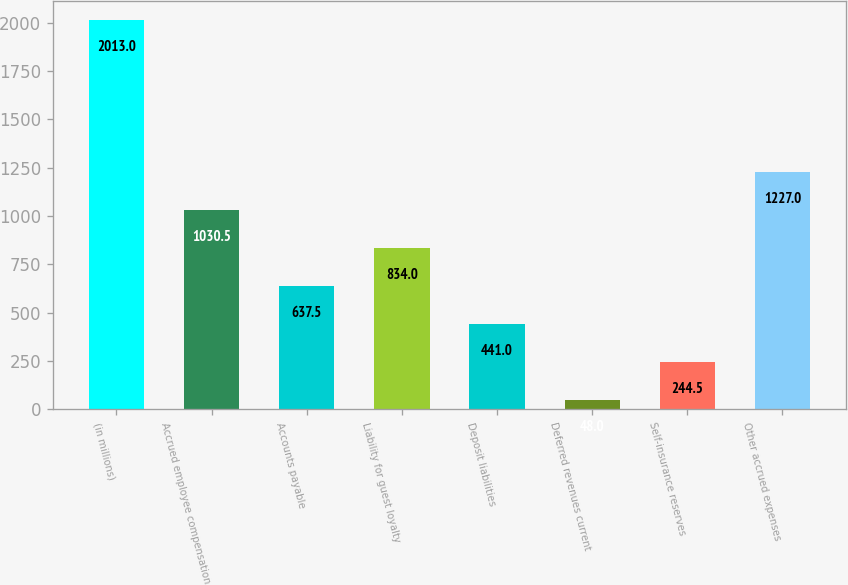<chart> <loc_0><loc_0><loc_500><loc_500><bar_chart><fcel>(in millions)<fcel>Accrued employee compensation<fcel>Accounts payable<fcel>Liability for guest loyalty<fcel>Deposit liabilities<fcel>Deferred revenues current<fcel>Self-insurance reserves<fcel>Other accrued expenses<nl><fcel>2013<fcel>1030.5<fcel>637.5<fcel>834<fcel>441<fcel>48<fcel>244.5<fcel>1227<nl></chart> 